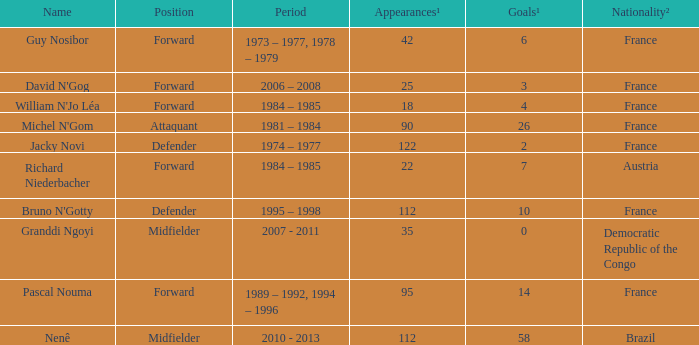How many players are from the country of Brazil? 1.0. Could you parse the entire table? {'header': ['Name', 'Position', 'Period', 'Appearances¹', 'Goals¹', 'Nationality²'], 'rows': [['Guy Nosibor', 'Forward', '1973 – 1977, 1978 – 1979', '42', '6', 'France'], ["David N'Gog", 'Forward', '2006 – 2008', '25', '3', 'France'], ["William N'Jo Léa", 'Forward', '1984 – 1985', '18', '4', 'France'], ["Michel N'Gom", 'Attaquant', '1981 – 1984', '90', '26', 'France'], ['Jacky Novi', 'Defender', '1974 – 1977', '122', '2', 'France'], ['Richard Niederbacher', 'Forward', '1984 – 1985', '22', '7', 'Austria'], ["Bruno N'Gotty", 'Defender', '1995 – 1998', '112', '10', 'France'], ['Granddi Ngoyi', 'Midfielder', '2007 - 2011', '35', '0', 'Democratic Republic of the Congo'], ['Pascal Nouma', 'Forward', '1989 – 1992, 1994 – 1996', '95', '14', 'France'], ['Nenê', 'Midfielder', '2010 - 2013', '112', '58', 'Brazil']]} 